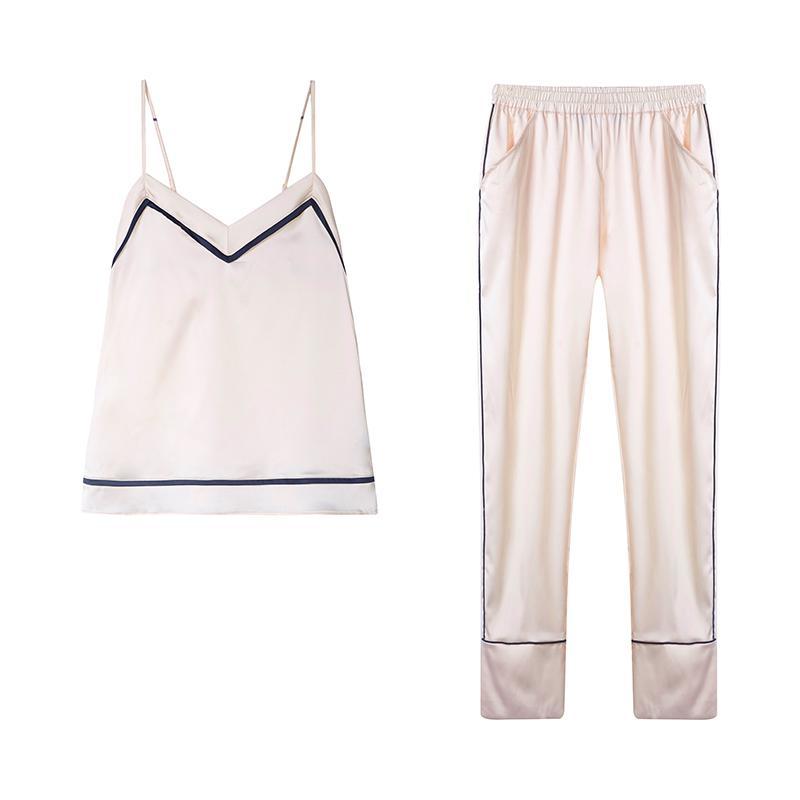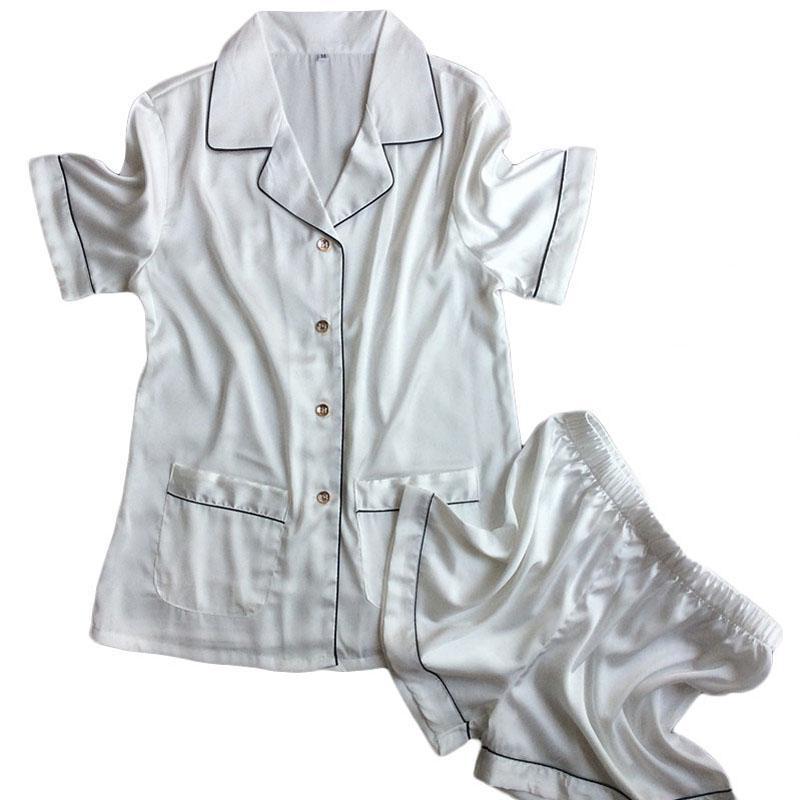The first image is the image on the left, the second image is the image on the right. Analyze the images presented: Is the assertion "there is a short sleeved two piece pajama with a callar and front pockets" valid? Answer yes or no. Yes. The first image is the image on the left, the second image is the image on the right. Analyze the images presented: Is the assertion "The right image has a pair of unfolded shorts." valid? Answer yes or no. Yes. 